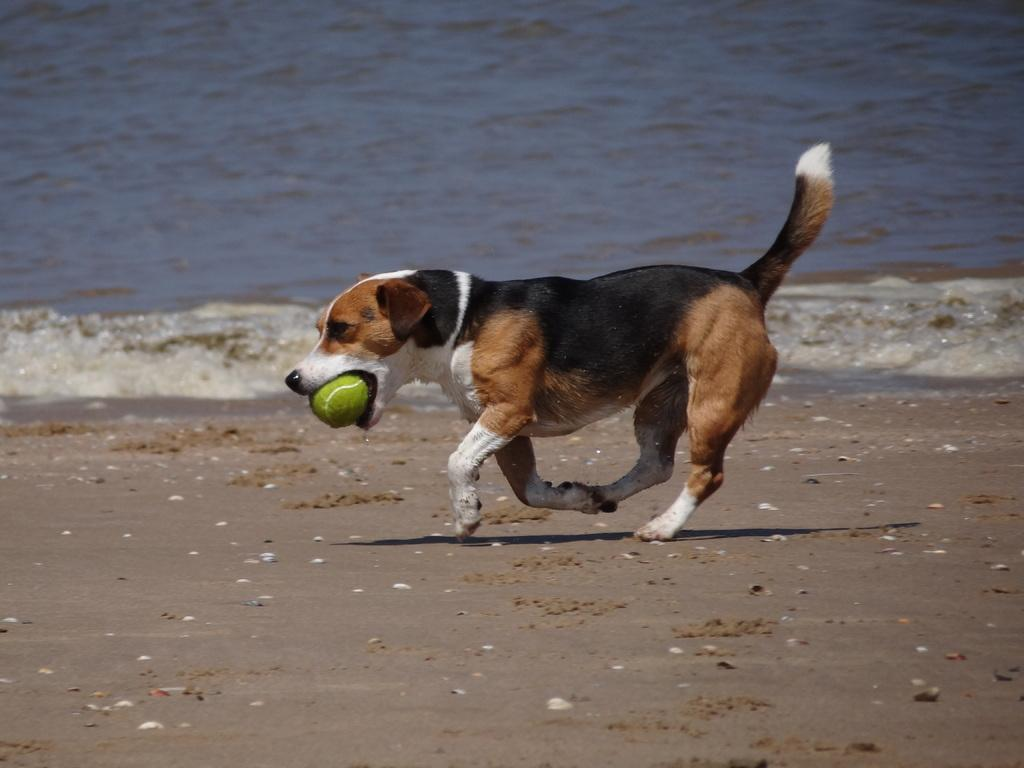What animal can be seen in the image? There is a dog in the image. What is the dog doing in the image? The dog is running. What is the dog holding in its mouth? The dog is holding a ball in its mouth. What can be seen in the background of the image? There is water visible in the background of the image. What type of yam can be seen growing in the image? There is no yam present in the image; it features a dog running while holding a ball in its mouth. 